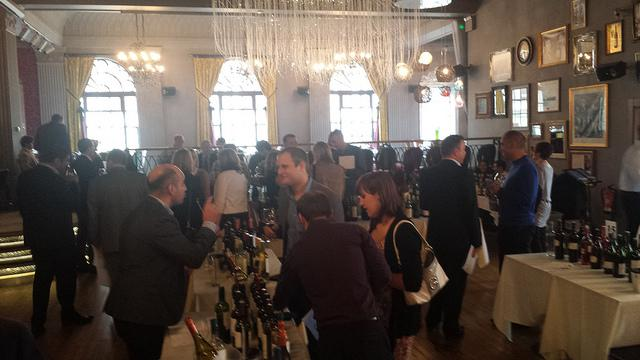New Orleans is inventor of what? jazz 